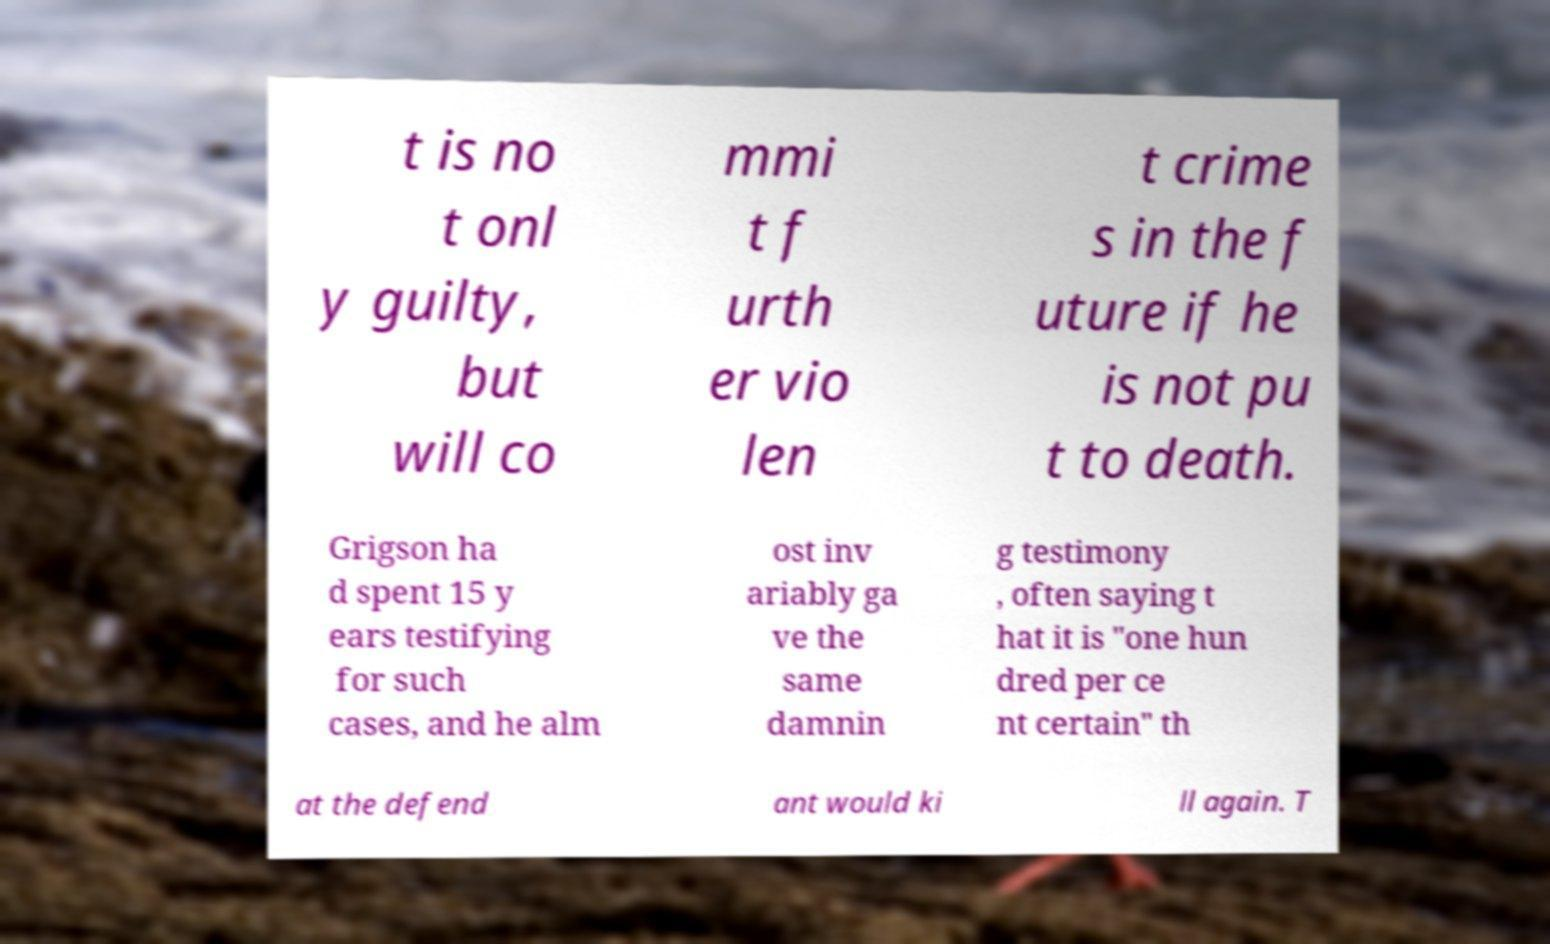I need the written content from this picture converted into text. Can you do that? t is no t onl y guilty, but will co mmi t f urth er vio len t crime s in the f uture if he is not pu t to death. Grigson ha d spent 15 y ears testifying for such cases, and he alm ost inv ariably ga ve the same damnin g testimony , often saying t hat it is "one hun dred per ce nt certain" th at the defend ant would ki ll again. T 